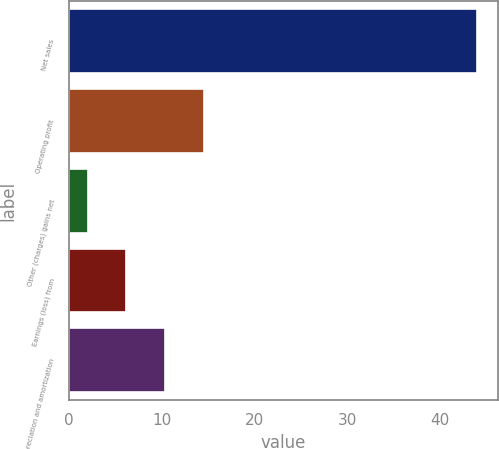Convert chart. <chart><loc_0><loc_0><loc_500><loc_500><bar_chart><fcel>Net sales<fcel>Operating profit<fcel>Other (charges) gains net<fcel>Earnings (loss) from<fcel>Depreciation and amortization<nl><fcel>44<fcel>14.6<fcel>2<fcel>6.2<fcel>10.4<nl></chart> 